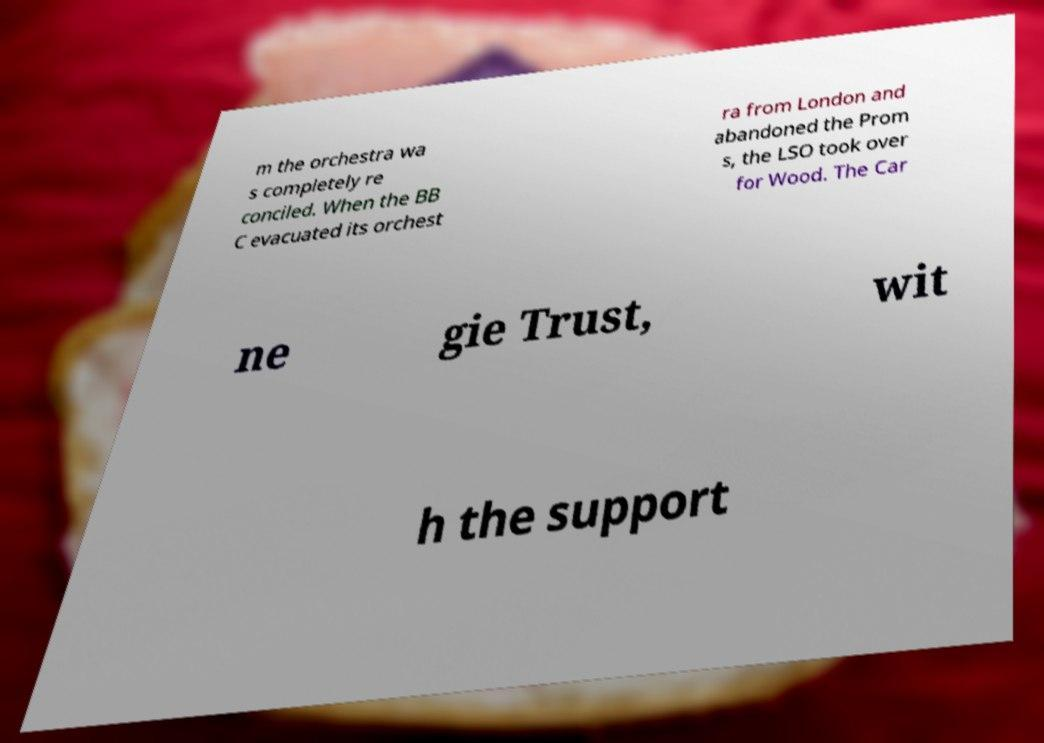There's text embedded in this image that I need extracted. Can you transcribe it verbatim? m the orchestra wa s completely re conciled. When the BB C evacuated its orchest ra from London and abandoned the Prom s, the LSO took over for Wood. The Car ne gie Trust, wit h the support 